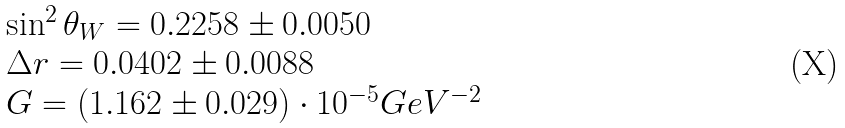<formula> <loc_0><loc_0><loc_500><loc_500>\begin{array} { l } \sin ^ { 2 } \theta _ { W } = 0 . 2 2 5 8 \pm 0 . 0 0 5 0 \\ \Delta r = 0 . 0 4 0 2 \pm 0 . 0 0 8 8 \\ G = ( 1 . 1 6 2 \pm 0 . 0 2 9 ) \cdot 1 0 ^ { - 5 } G e V ^ { - 2 } \end{array}</formula> 